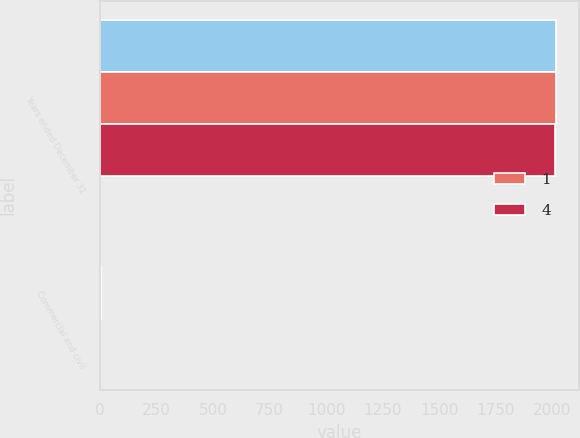Convert chart. <chart><loc_0><loc_0><loc_500><loc_500><stacked_bar_chart><ecel><fcel>Years ended December 31<fcel>Commercial and civil<nl><fcel>nan<fcel>2015<fcel>3<nl><fcel>1<fcel>2014<fcel>5<nl><fcel>4<fcel>2013<fcel>3<nl></chart> 